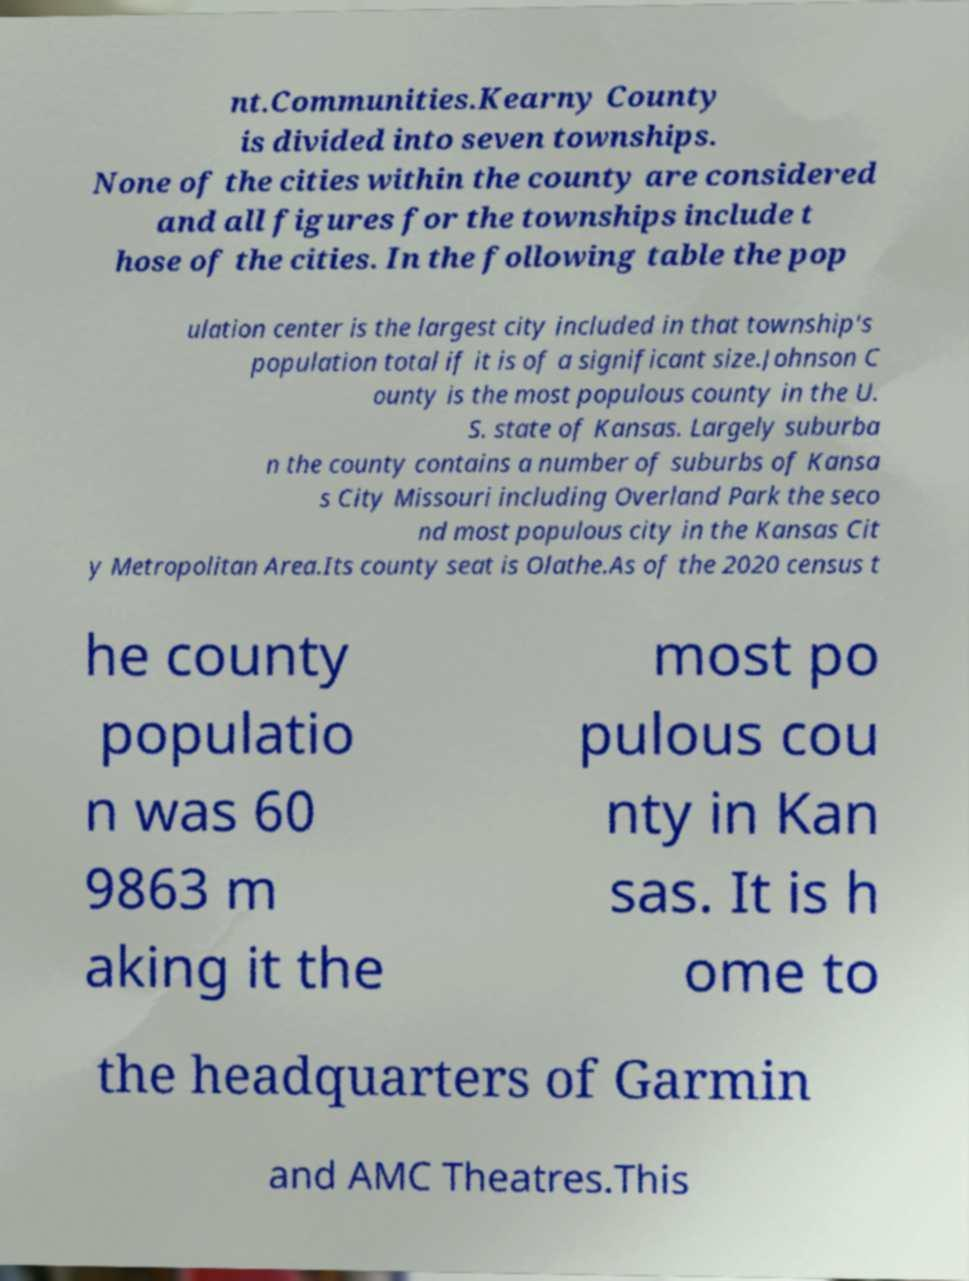Please identify and transcribe the text found in this image. nt.Communities.Kearny County is divided into seven townships. None of the cities within the county are considered and all figures for the townships include t hose of the cities. In the following table the pop ulation center is the largest city included in that township's population total if it is of a significant size.Johnson C ounty is the most populous county in the U. S. state of Kansas. Largely suburba n the county contains a number of suburbs of Kansa s City Missouri including Overland Park the seco nd most populous city in the Kansas Cit y Metropolitan Area.Its county seat is Olathe.As of the 2020 census t he county populatio n was 60 9863 m aking it the most po pulous cou nty in Kan sas. It is h ome to the headquarters of Garmin and AMC Theatres.This 